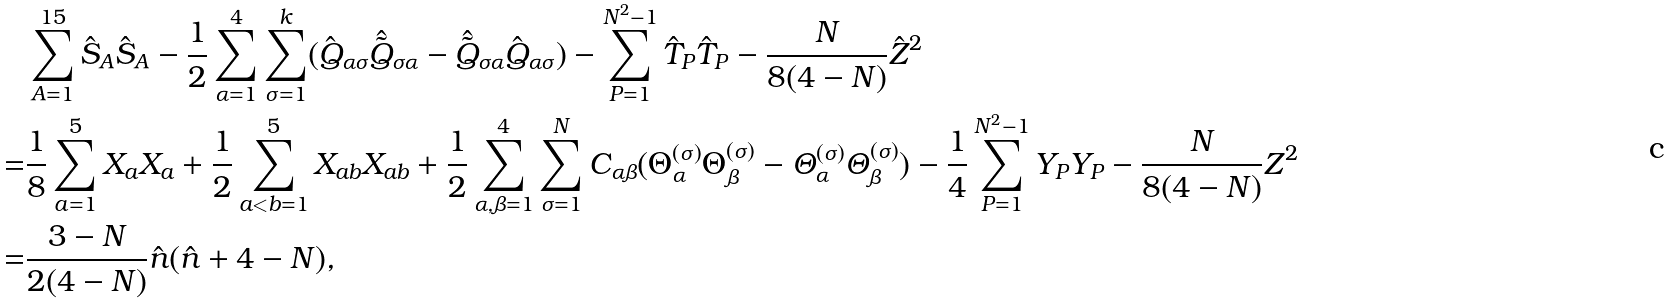Convert formula to latex. <formula><loc_0><loc_0><loc_500><loc_500>& \sum _ { A = 1 } ^ { 1 5 } \hat { S } _ { A } \hat { S } _ { A } - \frac { 1 } { 2 } \sum _ { \alpha = 1 } ^ { 4 } \sum _ { \sigma = 1 } ^ { k } ( \hat { Q } _ { \alpha \sigma } \hat { \tilde { Q } } _ { \sigma \alpha } - \hat { \tilde { Q } } _ { \sigma \alpha } \hat { Q } _ { \alpha \sigma } ) - \sum _ { P = 1 } ^ { N ^ { 2 } - 1 } \hat { T } _ { P } \hat { T } _ { P } - \frac { N } { 8 ( 4 - N ) } \hat { Z } ^ { 2 } \\ = & \frac { 1 } { 8 } \sum _ { a = 1 } ^ { 5 } X _ { a } X _ { a } + \frac { 1 } { 2 } \sum _ { a < b = 1 } ^ { 5 } X _ { a b } X _ { a b } + \frac { 1 } { 2 } \sum _ { \alpha , \beta = 1 } ^ { 4 } \sum _ { \sigma = 1 } ^ { N } C _ { \alpha \beta } ( \Theta _ { \alpha } ^ { ( \sigma ) } \Theta _ { \beta } ^ { ( \sigma ) } - \varTheta _ { \alpha } ^ { ( \sigma ) } \varTheta _ { \beta } ^ { ( \sigma ) } ) - \frac { 1 } { 4 } \sum _ { P = 1 } ^ { N ^ { 2 } - 1 } Y _ { P } Y _ { P } - \frac { N } { 8 ( 4 - N ) } Z ^ { 2 } \\ = & \frac { 3 - N } { 2 ( 4 - N ) } \hat { n } ( \hat { n } + 4 - N ) ,</formula> 